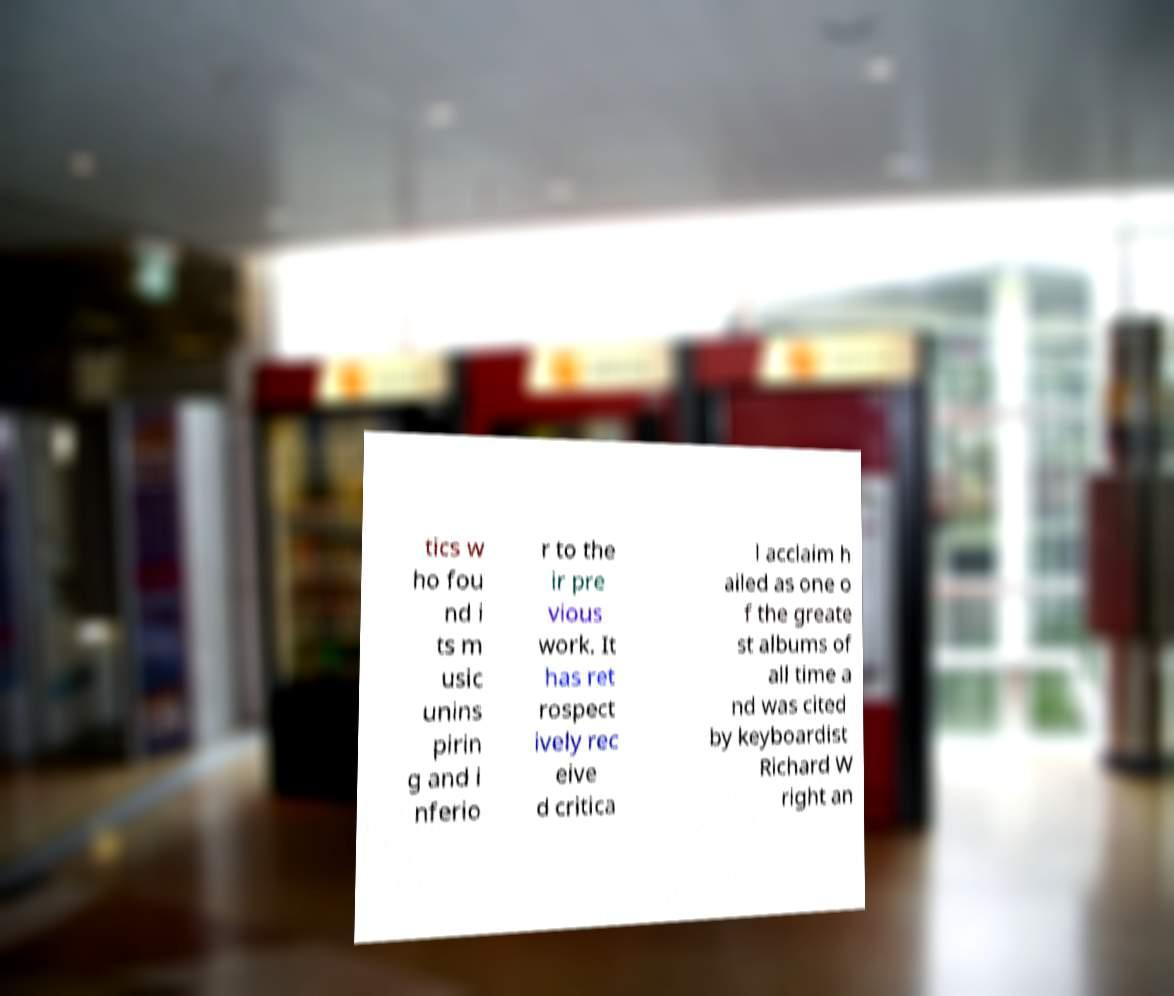For documentation purposes, I need the text within this image transcribed. Could you provide that? tics w ho fou nd i ts m usic unins pirin g and i nferio r to the ir pre vious work. It has ret rospect ively rec eive d critica l acclaim h ailed as one o f the greate st albums of all time a nd was cited by keyboardist Richard W right an 